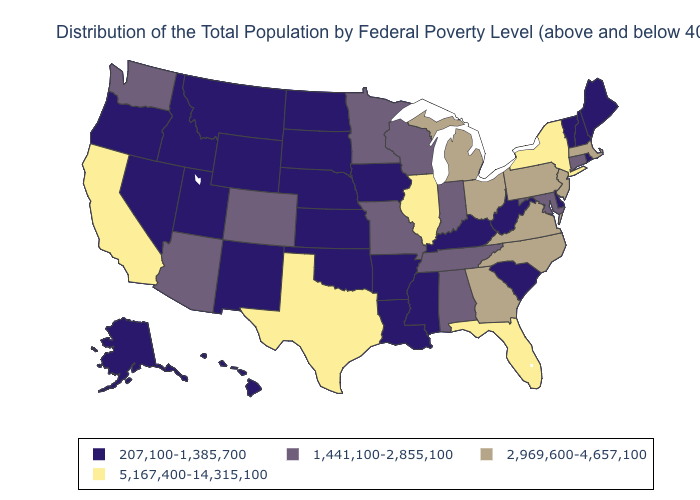Name the states that have a value in the range 5,167,400-14,315,100?
Short answer required. California, Florida, Illinois, New York, Texas. What is the value of Oklahoma?
Give a very brief answer. 207,100-1,385,700. Which states have the lowest value in the USA?
Quick response, please. Alaska, Arkansas, Delaware, Hawaii, Idaho, Iowa, Kansas, Kentucky, Louisiana, Maine, Mississippi, Montana, Nebraska, Nevada, New Hampshire, New Mexico, North Dakota, Oklahoma, Oregon, Rhode Island, South Carolina, South Dakota, Utah, Vermont, West Virginia, Wyoming. What is the highest value in the USA?
Be succinct. 5,167,400-14,315,100. What is the lowest value in states that border Illinois?
Concise answer only. 207,100-1,385,700. Which states have the highest value in the USA?
Give a very brief answer. California, Florida, Illinois, New York, Texas. What is the lowest value in the South?
Answer briefly. 207,100-1,385,700. Does the map have missing data?
Short answer required. No. Which states have the highest value in the USA?
Be succinct. California, Florida, Illinois, New York, Texas. Name the states that have a value in the range 5,167,400-14,315,100?
Keep it brief. California, Florida, Illinois, New York, Texas. Name the states that have a value in the range 2,969,600-4,657,100?
Write a very short answer. Georgia, Massachusetts, Michigan, New Jersey, North Carolina, Ohio, Pennsylvania, Virginia. Name the states that have a value in the range 5,167,400-14,315,100?
Short answer required. California, Florida, Illinois, New York, Texas. Among the states that border South Dakota , which have the highest value?
Concise answer only. Minnesota. Does Nevada have a lower value than Mississippi?
Be succinct. No. Among the states that border Missouri , does Tennessee have the lowest value?
Quick response, please. No. 